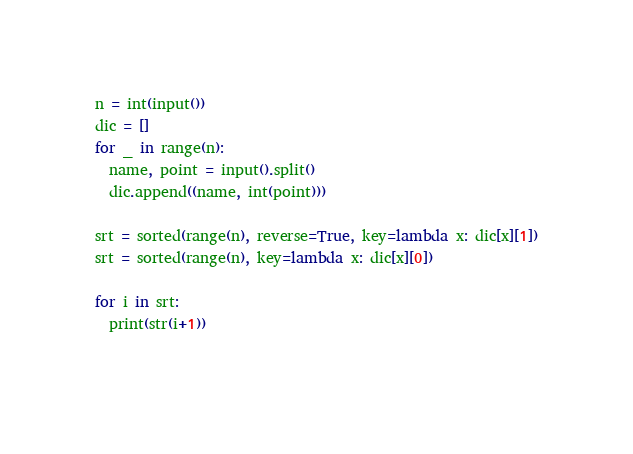Convert code to text. <code><loc_0><loc_0><loc_500><loc_500><_Python_>n = int(input())
dic = []
for _ in range(n):
  name, point = input().split()
  dic.append((name, int(point)))

srt = sorted(range(n), reverse=True, key=lambda x: dic[x][1])
srt = sorted(range(n), key=lambda x: dic[x][0])

for i in srt:
  print(str(i+1))
             </code> 